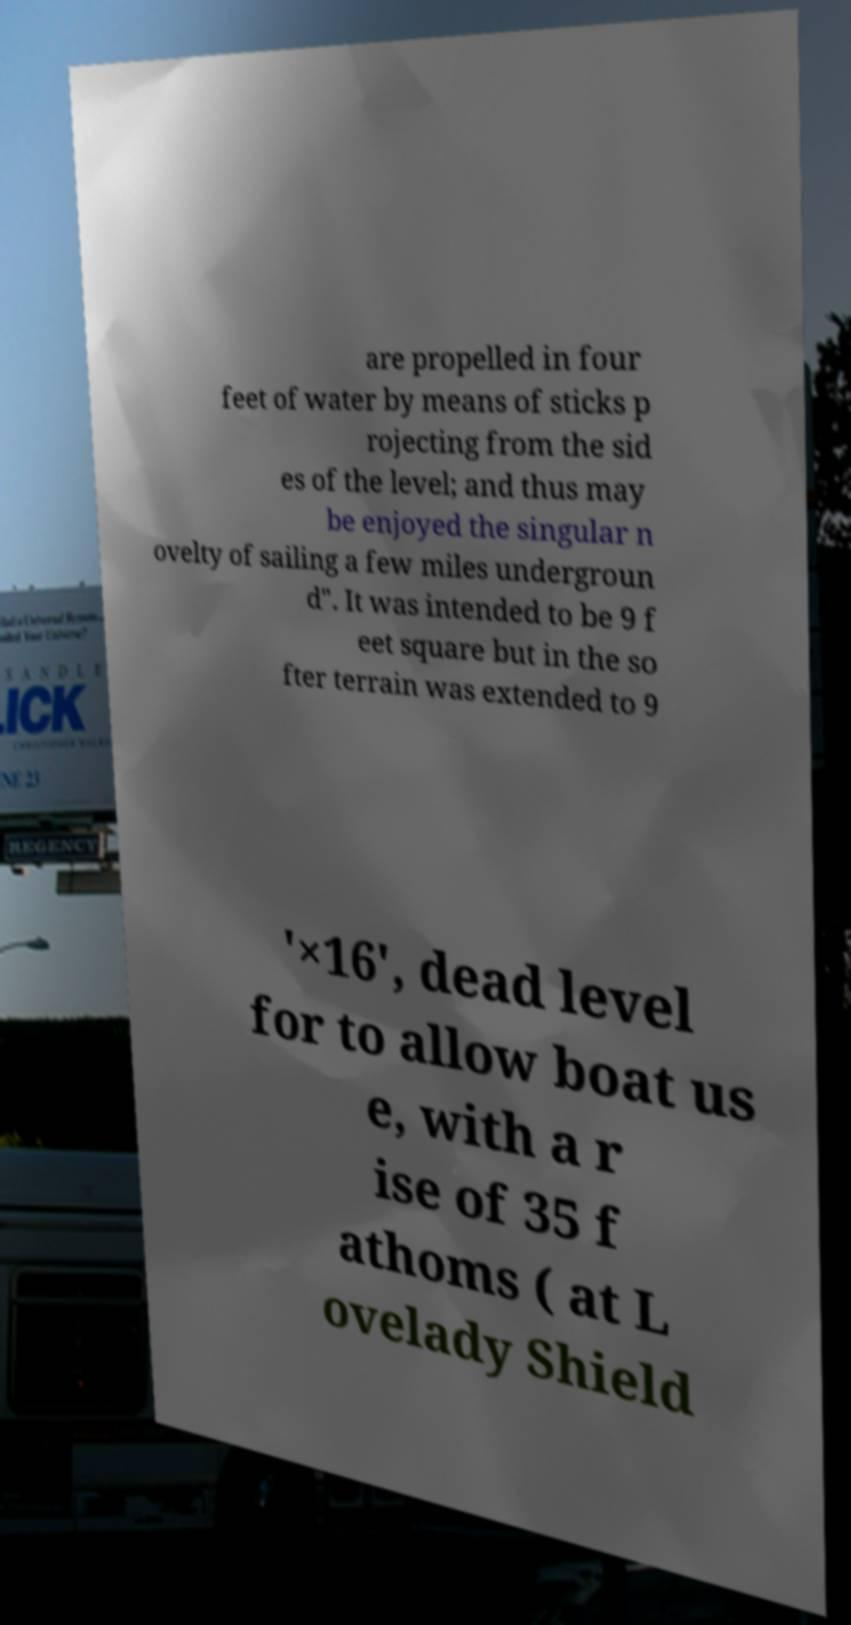Please read and relay the text visible in this image. What does it say? are propelled in four feet of water by means of sticks p rojecting from the sid es of the level; and thus may be enjoyed the singular n ovelty of sailing a few miles undergroun d". It was intended to be 9 f eet square but in the so fter terrain was extended to 9 '×16', dead level for to allow boat us e, with a r ise of 35 f athoms ( at L ovelady Shield 